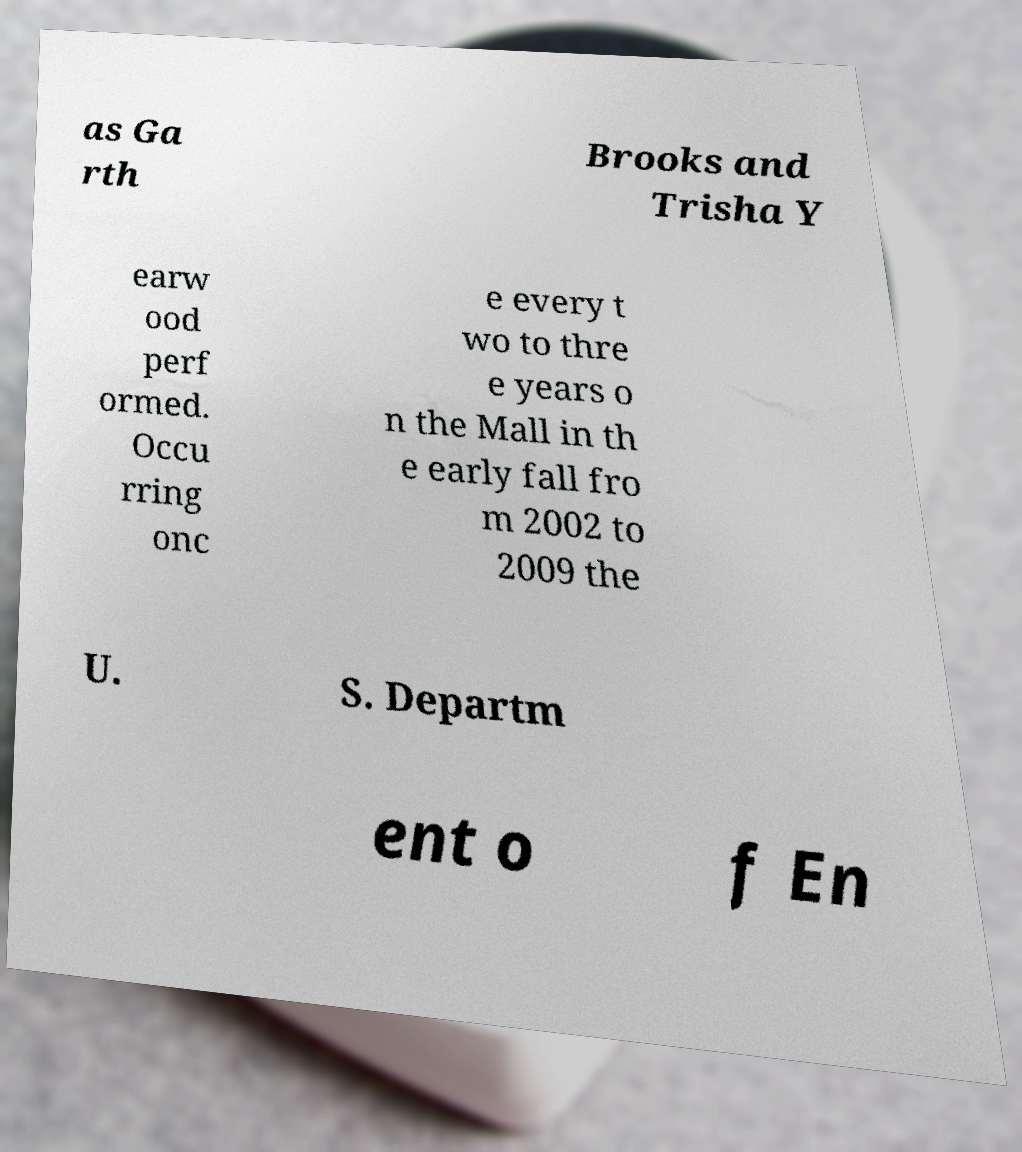Can you accurately transcribe the text from the provided image for me? as Ga rth Brooks and Trisha Y earw ood perf ormed. Occu rring onc e every t wo to thre e years o n the Mall in th e early fall fro m 2002 to 2009 the U. S. Departm ent o f En 